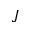Convert formula to latex. <formula><loc_0><loc_0><loc_500><loc_500>J</formula> 